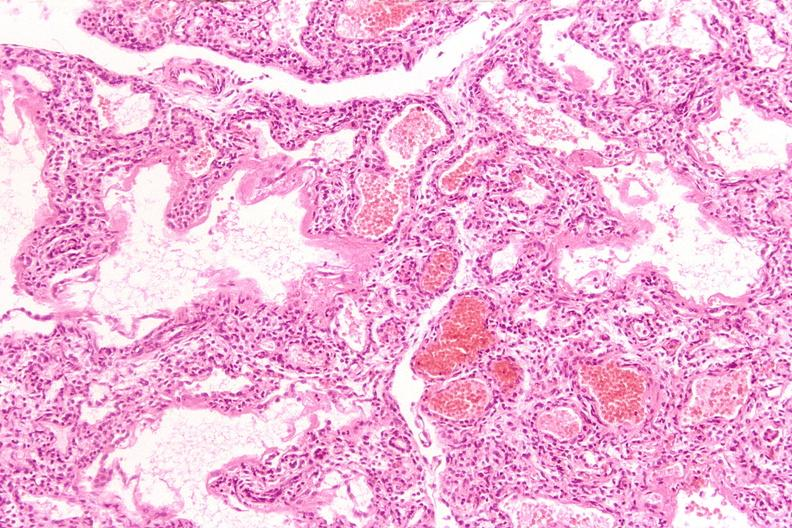what does this image show?
Answer the question using a single word or phrase. Lungs 